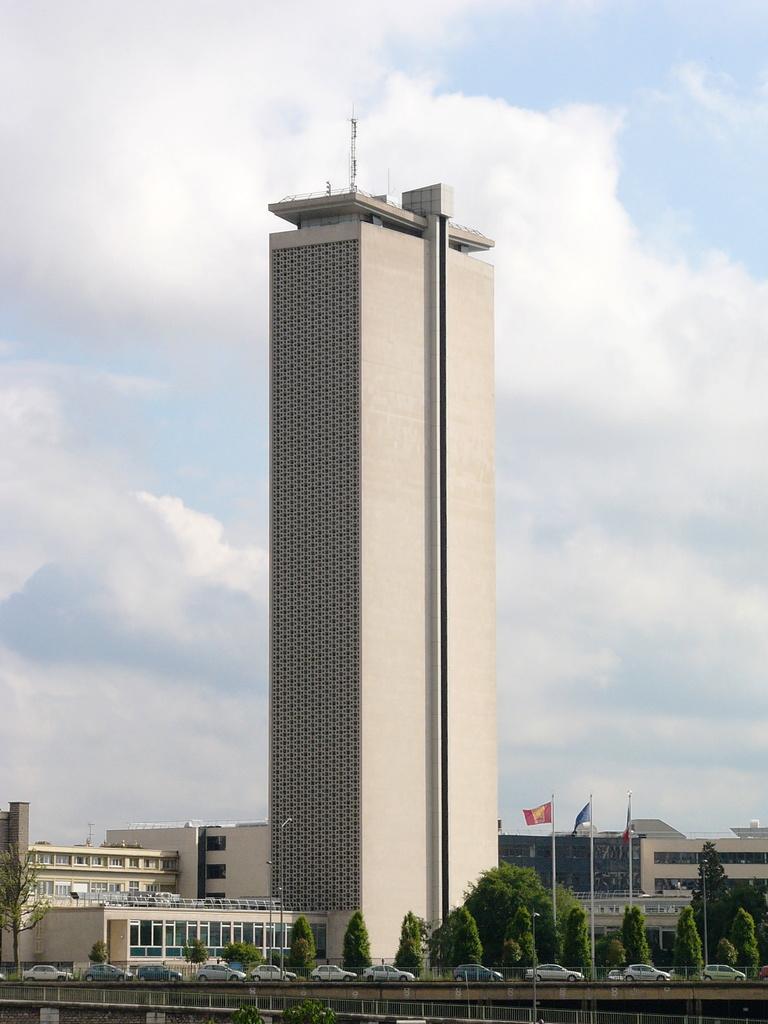Please provide a concise description of this image. In this image I see number of buildings and I see 3 flags over here which are colorful and I see number of trees and I can also see number of cars. In the background I see the sky. 